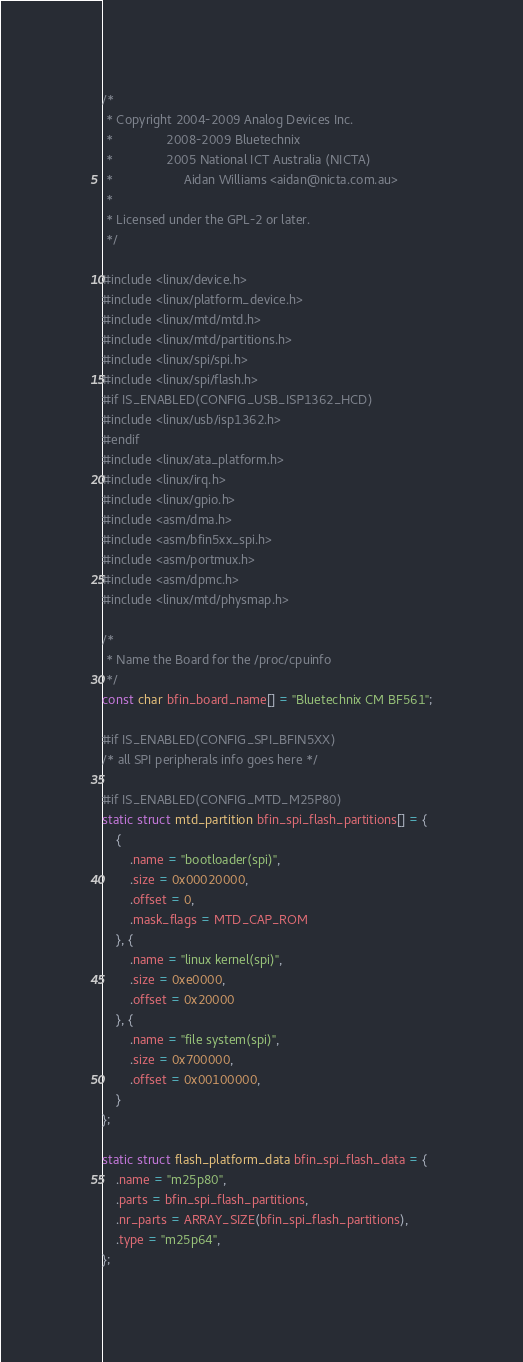<code> <loc_0><loc_0><loc_500><loc_500><_C_>/*
 * Copyright 2004-2009 Analog Devices Inc.
 *               2008-2009 Bluetechnix
 *               2005 National ICT Australia (NICTA)
 *                    Aidan Williams <aidan@nicta.com.au>
 *
 * Licensed under the GPL-2 or later.
 */

#include <linux/device.h>
#include <linux/platform_device.h>
#include <linux/mtd/mtd.h>
#include <linux/mtd/partitions.h>
#include <linux/spi/spi.h>
#include <linux/spi/flash.h>
#if IS_ENABLED(CONFIG_USB_ISP1362_HCD)
#include <linux/usb/isp1362.h>
#endif
#include <linux/ata_platform.h>
#include <linux/irq.h>
#include <linux/gpio.h>
#include <asm/dma.h>
#include <asm/bfin5xx_spi.h>
#include <asm/portmux.h>
#include <asm/dpmc.h>
#include <linux/mtd/physmap.h>

/*
 * Name the Board for the /proc/cpuinfo
 */
const char bfin_board_name[] = "Bluetechnix CM BF561";

#if IS_ENABLED(CONFIG_SPI_BFIN5XX)
/* all SPI peripherals info goes here */

#if IS_ENABLED(CONFIG_MTD_M25P80)
static struct mtd_partition bfin_spi_flash_partitions[] = {
	{
		.name = "bootloader(spi)",
		.size = 0x00020000,
		.offset = 0,
		.mask_flags = MTD_CAP_ROM
	}, {
		.name = "linux kernel(spi)",
		.size = 0xe0000,
		.offset = 0x20000
	}, {
		.name = "file system(spi)",
		.size = 0x700000,
		.offset = 0x00100000,
	}
};

static struct flash_platform_data bfin_spi_flash_data = {
	.name = "m25p80",
	.parts = bfin_spi_flash_partitions,
	.nr_parts = ARRAY_SIZE(bfin_spi_flash_partitions),
	.type = "m25p64",
};
</code> 